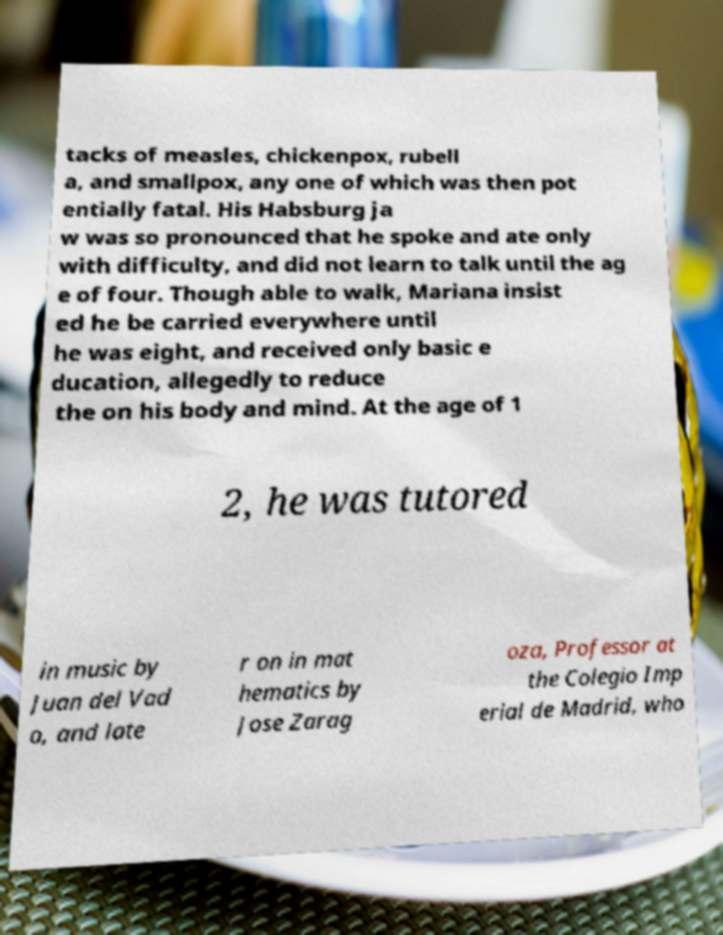I need the written content from this picture converted into text. Can you do that? tacks of measles, chickenpox, rubell a, and smallpox, any one of which was then pot entially fatal. His Habsburg ja w was so pronounced that he spoke and ate only with difficulty, and did not learn to talk until the ag e of four. Though able to walk, Mariana insist ed he be carried everywhere until he was eight, and received only basic e ducation, allegedly to reduce the on his body and mind. At the age of 1 2, he was tutored in music by Juan del Vad o, and late r on in mat hematics by Jose Zarag oza, Professor at the Colegio Imp erial de Madrid, who 